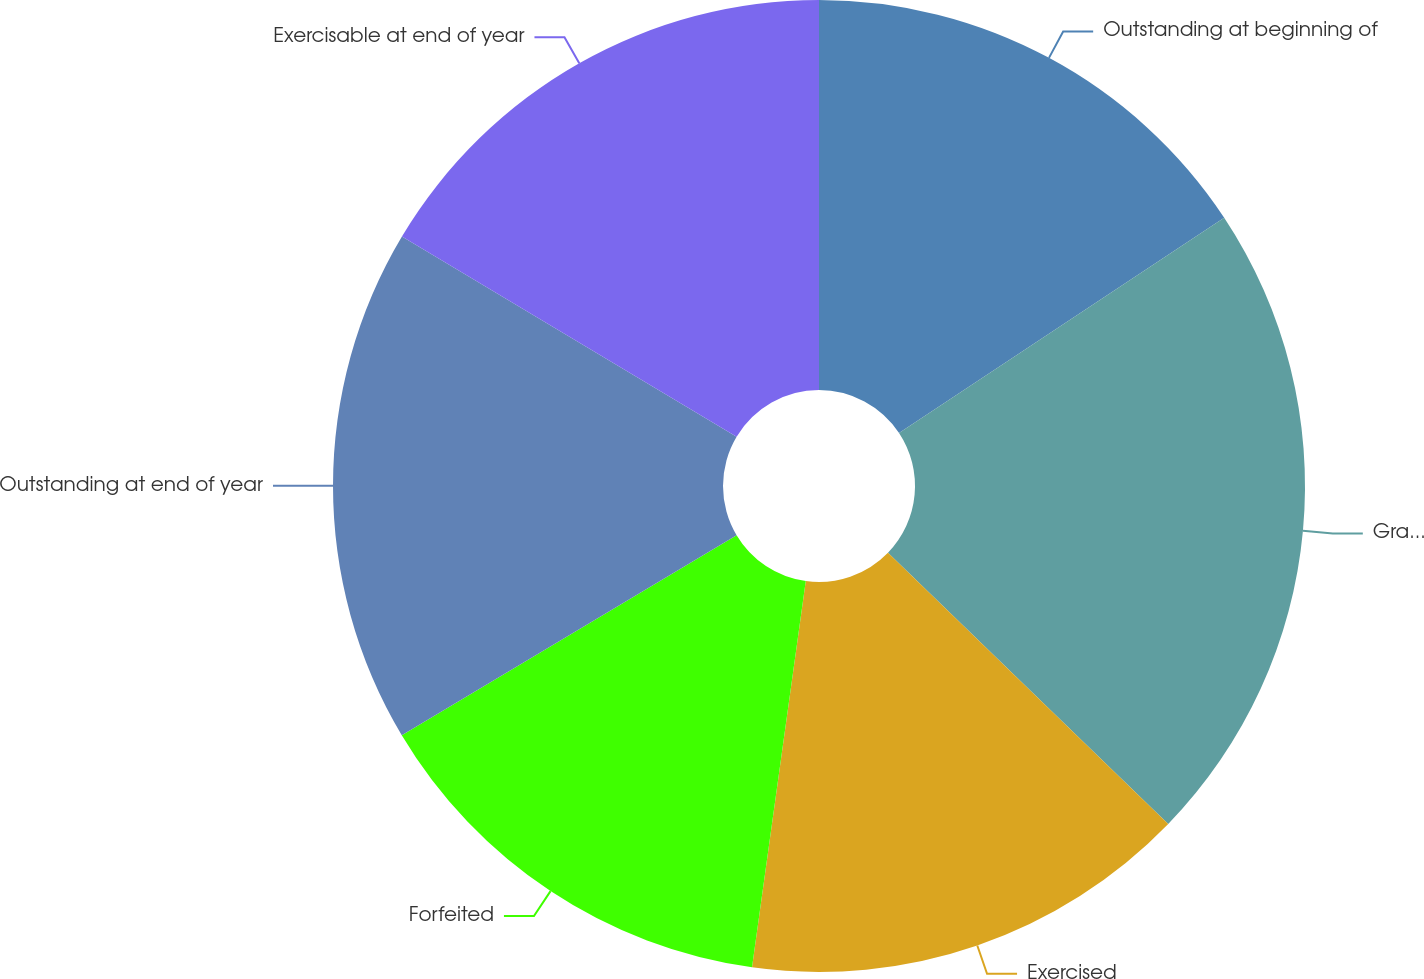<chart> <loc_0><loc_0><loc_500><loc_500><pie_chart><fcel>Outstanding at beginning of<fcel>Granted(2)<fcel>Exercised<fcel>Forfeited<fcel>Outstanding at end of year<fcel>Exercisable at end of year<nl><fcel>15.69%<fcel>21.55%<fcel>14.96%<fcel>14.23%<fcel>17.15%<fcel>16.42%<nl></chart> 